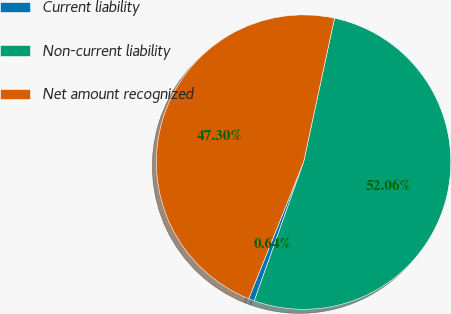Convert chart. <chart><loc_0><loc_0><loc_500><loc_500><pie_chart><fcel>Current liability<fcel>Non-current liability<fcel>Net amount recognized<nl><fcel>0.64%<fcel>52.07%<fcel>47.3%<nl></chart> 